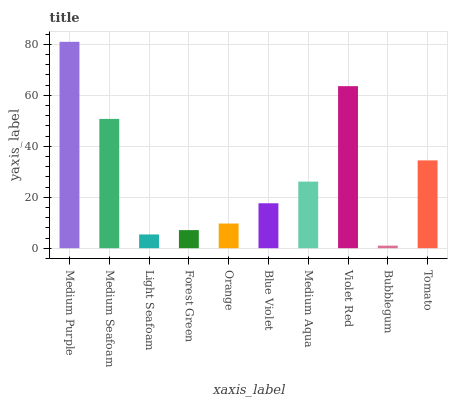Is Bubblegum the minimum?
Answer yes or no. Yes. Is Medium Purple the maximum?
Answer yes or no. Yes. Is Medium Seafoam the minimum?
Answer yes or no. No. Is Medium Seafoam the maximum?
Answer yes or no. No. Is Medium Purple greater than Medium Seafoam?
Answer yes or no. Yes. Is Medium Seafoam less than Medium Purple?
Answer yes or no. Yes. Is Medium Seafoam greater than Medium Purple?
Answer yes or no. No. Is Medium Purple less than Medium Seafoam?
Answer yes or no. No. Is Medium Aqua the high median?
Answer yes or no. Yes. Is Blue Violet the low median?
Answer yes or no. Yes. Is Light Seafoam the high median?
Answer yes or no. No. Is Forest Green the low median?
Answer yes or no. No. 